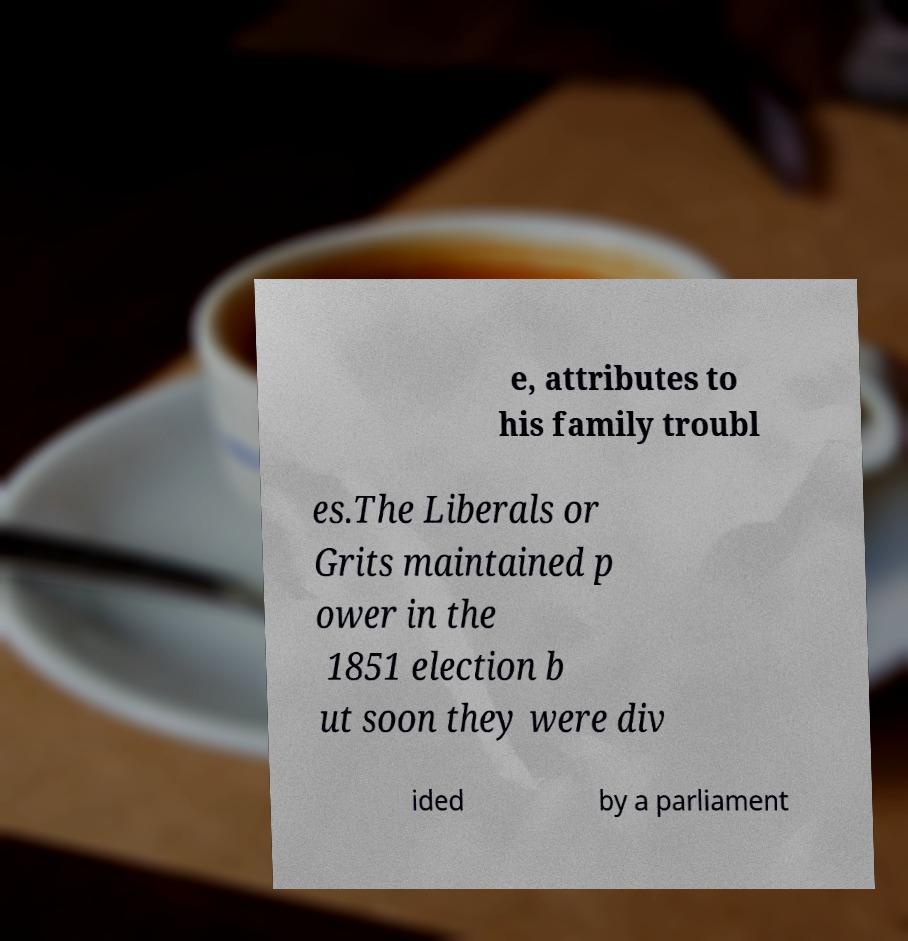What messages or text are displayed in this image? I need them in a readable, typed format. e, attributes to his family troubl es.The Liberals or Grits maintained p ower in the 1851 election b ut soon they were div ided by a parliament 